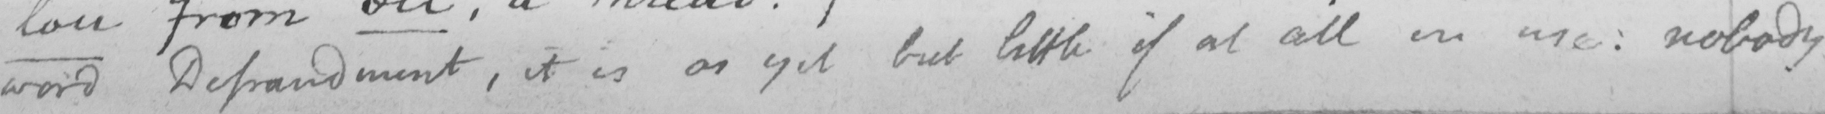What text is written in this handwritten line? word Defraudment , it is as yet but little if at all in use :  nobody 